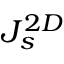<formula> <loc_0><loc_0><loc_500><loc_500>J _ { s } ^ { 2 D }</formula> 